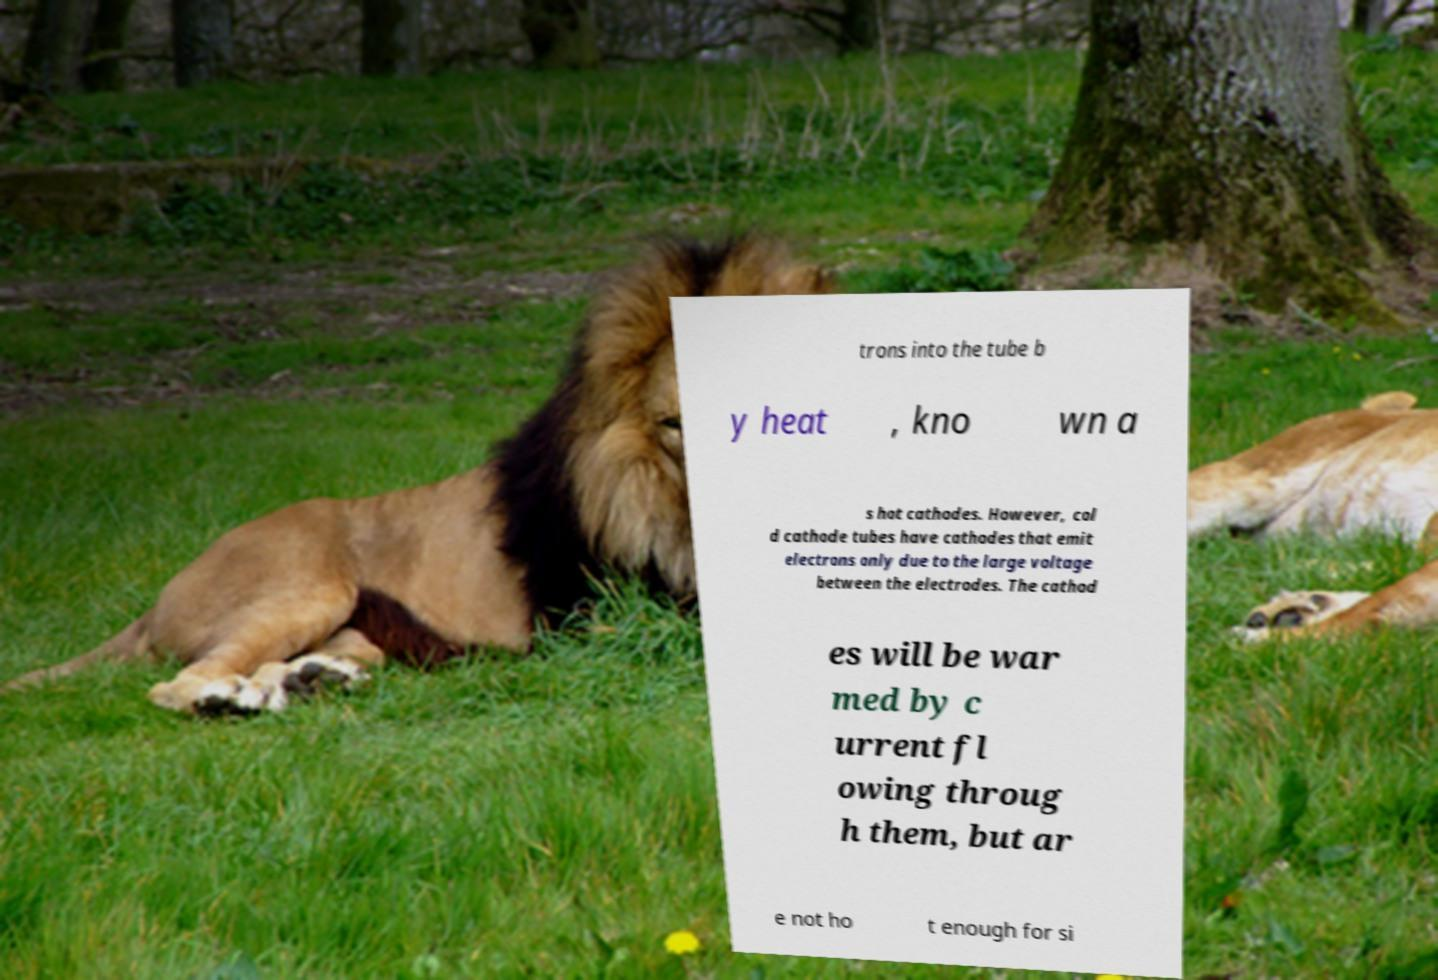What messages or text are displayed in this image? I need them in a readable, typed format. trons into the tube b y heat , kno wn a s hot cathodes. However, col d cathode tubes have cathodes that emit electrons only due to the large voltage between the electrodes. The cathod es will be war med by c urrent fl owing throug h them, but ar e not ho t enough for si 